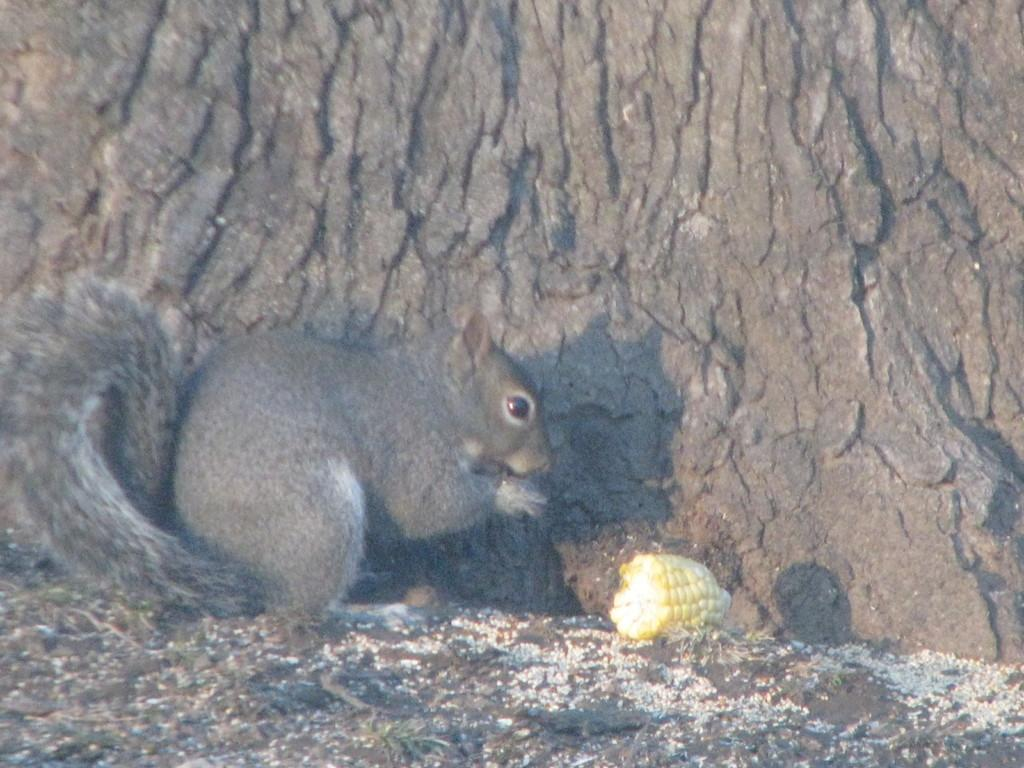What animal can be seen in the image? There is a squirrel in the image. What is the squirrel interacting with in the image? There is corn in front of the squirrel. What can be seen in the background of the image? The trunk of a tree is visible in the background of the image. What time of day is it in the image, and how does the squirrel plan to swim to the other side of the lake? The time of day is not mentioned in the image, and there is no lake or indication of swimming in the image. 